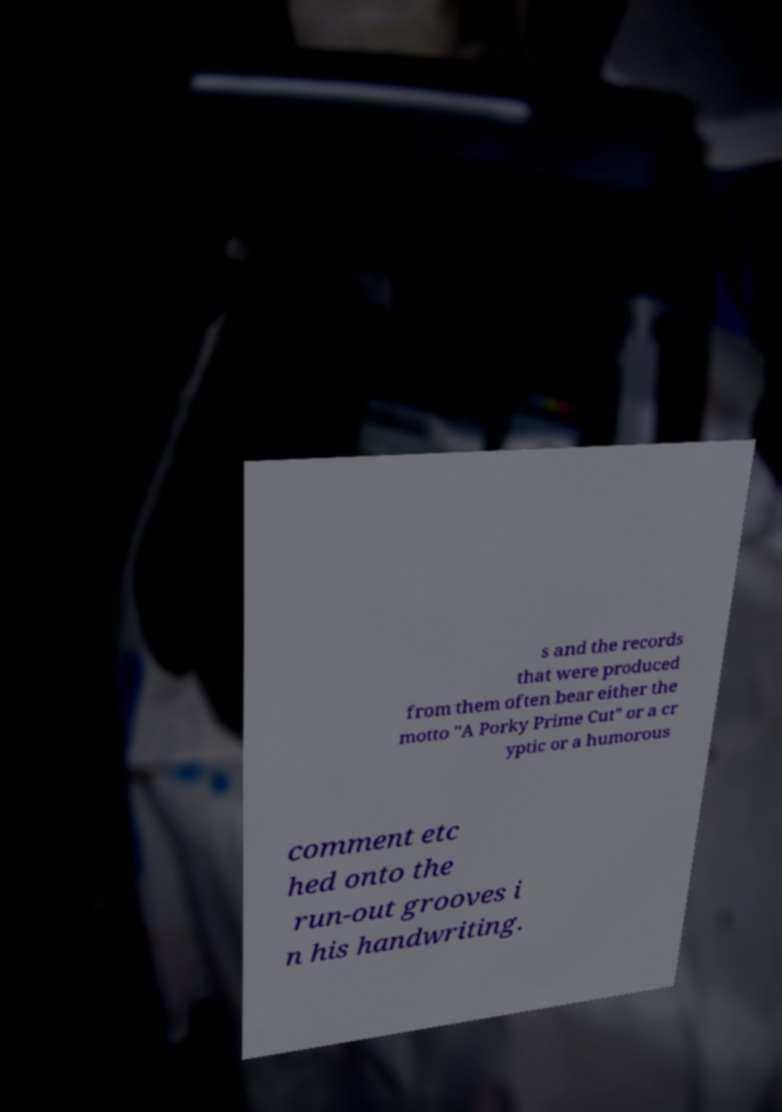Please read and relay the text visible in this image. What does it say? s and the records that were produced from them often bear either the motto "A Porky Prime Cut" or a cr yptic or a humorous comment etc hed onto the run-out grooves i n his handwriting. 